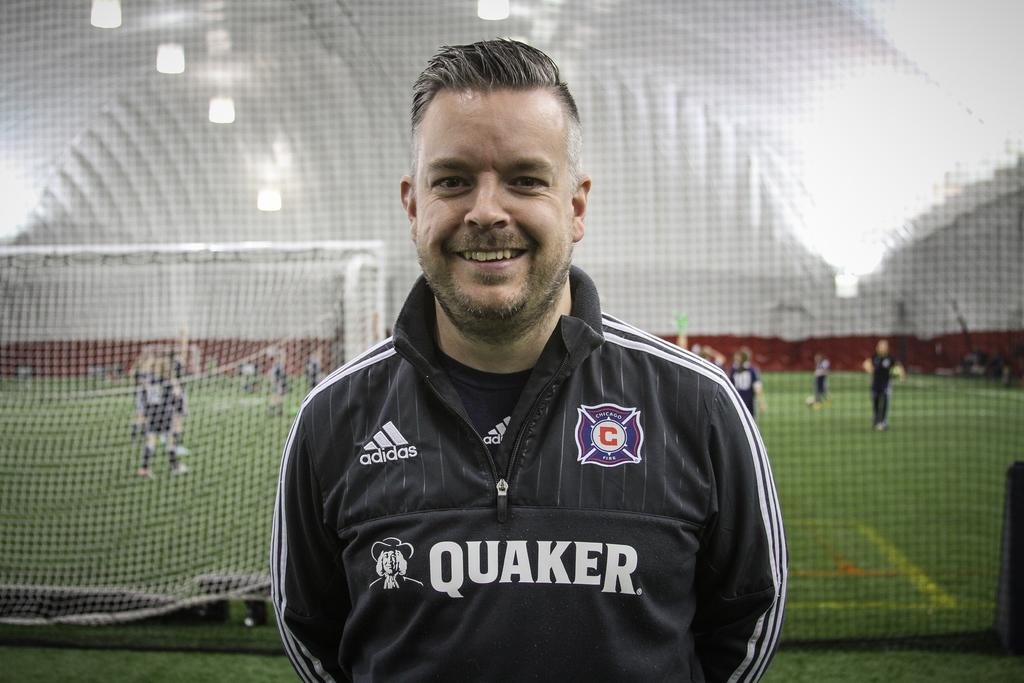<image>
Present a compact description of the photo's key features. A man standing in front of a soccer goal in a black addidas jersey with Quaker written on it. 